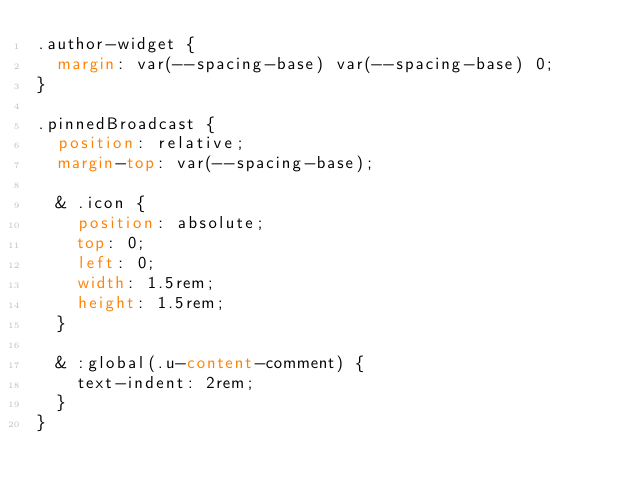<code> <loc_0><loc_0><loc_500><loc_500><_CSS_>.author-widget {
  margin: var(--spacing-base) var(--spacing-base) 0;
}

.pinnedBroadcast {
  position: relative;
  margin-top: var(--spacing-base);

  & .icon {
    position: absolute;
    top: 0;
    left: 0;
    width: 1.5rem;
    height: 1.5rem;
  }

  & :global(.u-content-comment) {
    text-indent: 2rem;
  }
}
</code> 